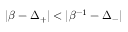Convert formula to latex. <formula><loc_0><loc_0><loc_500><loc_500>| \beta - \Delta _ { + } | < | \beta ^ { - 1 } - \Delta _ { - } |</formula> 